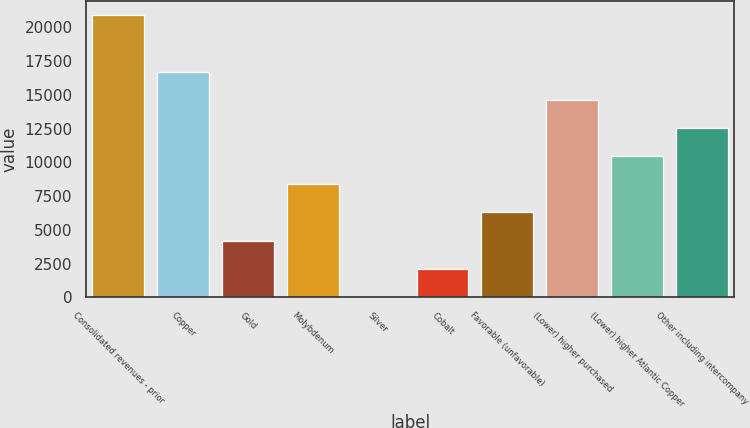Convert chart to OTSL. <chart><loc_0><loc_0><loc_500><loc_500><bar_chart><fcel>Consolidated revenues - prior<fcel>Copper<fcel>Gold<fcel>Molybdenum<fcel>Silver<fcel>Cobalt<fcel>Favorable (unfavorable)<fcel>(Lower) higher purchased<fcel>(Lower) higher Atlantic Copper<fcel>Other including intercompany<nl><fcel>20880<fcel>16712.8<fcel>4211.2<fcel>8378.4<fcel>44<fcel>2127.6<fcel>6294.8<fcel>14629.2<fcel>10462<fcel>12545.6<nl></chart> 